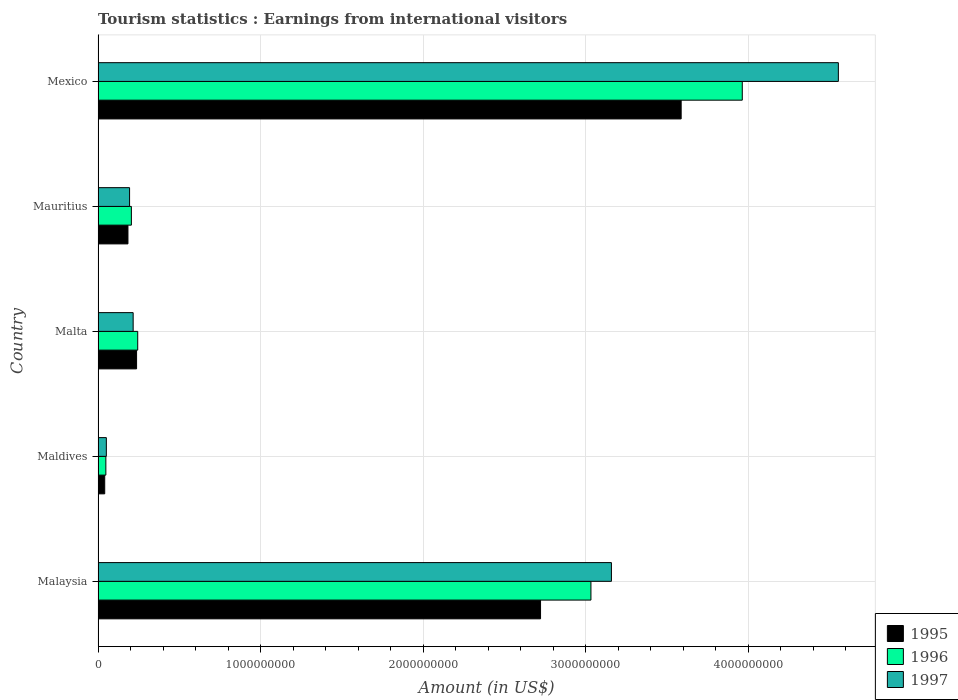How many different coloured bars are there?
Keep it short and to the point. 3. Are the number of bars per tick equal to the number of legend labels?
Your answer should be compact. Yes. Are the number of bars on each tick of the Y-axis equal?
Your answer should be compact. Yes. What is the label of the 1st group of bars from the top?
Keep it short and to the point. Mexico. What is the earnings from international visitors in 1996 in Malta?
Provide a short and direct response. 2.44e+08. Across all countries, what is the maximum earnings from international visitors in 1996?
Your answer should be compact. 3.96e+09. Across all countries, what is the minimum earnings from international visitors in 1997?
Provide a short and direct response. 5.10e+07. In which country was the earnings from international visitors in 1995 maximum?
Provide a succinct answer. Mexico. In which country was the earnings from international visitors in 1996 minimum?
Make the answer very short. Maldives. What is the total earnings from international visitors in 1996 in the graph?
Make the answer very short. 7.49e+09. What is the difference between the earnings from international visitors in 1996 in Malta and that in Mauritius?
Offer a terse response. 3.90e+07. What is the difference between the earnings from international visitors in 1996 in Mauritius and the earnings from international visitors in 1995 in Malta?
Make the answer very short. -3.20e+07. What is the average earnings from international visitors in 1997 per country?
Keep it short and to the point. 1.63e+09. What is the difference between the earnings from international visitors in 1995 and earnings from international visitors in 1996 in Malta?
Your answer should be compact. -7.00e+06. What is the ratio of the earnings from international visitors in 1995 in Malaysia to that in Malta?
Keep it short and to the point. 11.49. Is the earnings from international visitors in 1995 in Maldives less than that in Malta?
Make the answer very short. Yes. What is the difference between the highest and the second highest earnings from international visitors in 1995?
Your answer should be compact. 8.65e+08. What is the difference between the highest and the lowest earnings from international visitors in 1997?
Provide a succinct answer. 4.50e+09. Is the sum of the earnings from international visitors in 1995 in Malta and Mexico greater than the maximum earnings from international visitors in 1996 across all countries?
Your answer should be compact. No. What does the 1st bar from the bottom in Mauritius represents?
Your answer should be compact. 1995. Is it the case that in every country, the sum of the earnings from international visitors in 1995 and earnings from international visitors in 1996 is greater than the earnings from international visitors in 1997?
Offer a terse response. Yes. How many countries are there in the graph?
Provide a succinct answer. 5. Are the values on the major ticks of X-axis written in scientific E-notation?
Your answer should be very brief. No. Does the graph contain grids?
Offer a terse response. Yes. Where does the legend appear in the graph?
Provide a short and direct response. Bottom right. How are the legend labels stacked?
Your answer should be compact. Vertical. What is the title of the graph?
Give a very brief answer. Tourism statistics : Earnings from international visitors. Does "2015" appear as one of the legend labels in the graph?
Your answer should be very brief. No. What is the label or title of the X-axis?
Ensure brevity in your answer.  Amount (in US$). What is the Amount (in US$) of 1995 in Malaysia?
Ensure brevity in your answer.  2.72e+09. What is the Amount (in US$) in 1996 in Malaysia?
Your response must be concise. 3.03e+09. What is the Amount (in US$) in 1997 in Malaysia?
Offer a very short reply. 3.16e+09. What is the Amount (in US$) of 1995 in Maldives?
Your answer should be very brief. 4.10e+07. What is the Amount (in US$) of 1996 in Maldives?
Give a very brief answer. 4.80e+07. What is the Amount (in US$) of 1997 in Maldives?
Your response must be concise. 5.10e+07. What is the Amount (in US$) in 1995 in Malta?
Give a very brief answer. 2.37e+08. What is the Amount (in US$) of 1996 in Malta?
Keep it short and to the point. 2.44e+08. What is the Amount (in US$) in 1997 in Malta?
Your answer should be compact. 2.16e+08. What is the Amount (in US$) of 1995 in Mauritius?
Provide a succinct answer. 1.84e+08. What is the Amount (in US$) in 1996 in Mauritius?
Make the answer very short. 2.05e+08. What is the Amount (in US$) in 1997 in Mauritius?
Your answer should be very brief. 1.94e+08. What is the Amount (in US$) of 1995 in Mexico?
Make the answer very short. 3.59e+09. What is the Amount (in US$) of 1996 in Mexico?
Keep it short and to the point. 3.96e+09. What is the Amount (in US$) in 1997 in Mexico?
Keep it short and to the point. 4.55e+09. Across all countries, what is the maximum Amount (in US$) of 1995?
Ensure brevity in your answer.  3.59e+09. Across all countries, what is the maximum Amount (in US$) in 1996?
Keep it short and to the point. 3.96e+09. Across all countries, what is the maximum Amount (in US$) of 1997?
Provide a succinct answer. 4.55e+09. Across all countries, what is the minimum Amount (in US$) of 1995?
Provide a short and direct response. 4.10e+07. Across all countries, what is the minimum Amount (in US$) of 1996?
Your answer should be very brief. 4.80e+07. Across all countries, what is the minimum Amount (in US$) in 1997?
Ensure brevity in your answer.  5.10e+07. What is the total Amount (in US$) of 1995 in the graph?
Give a very brief answer. 6.77e+09. What is the total Amount (in US$) of 1996 in the graph?
Keep it short and to the point. 7.49e+09. What is the total Amount (in US$) in 1997 in the graph?
Ensure brevity in your answer.  8.17e+09. What is the difference between the Amount (in US$) of 1995 in Malaysia and that in Maldives?
Give a very brief answer. 2.68e+09. What is the difference between the Amount (in US$) of 1996 in Malaysia and that in Maldives?
Your response must be concise. 2.98e+09. What is the difference between the Amount (in US$) of 1997 in Malaysia and that in Maldives?
Offer a terse response. 3.11e+09. What is the difference between the Amount (in US$) of 1995 in Malaysia and that in Malta?
Make the answer very short. 2.48e+09. What is the difference between the Amount (in US$) of 1996 in Malaysia and that in Malta?
Your answer should be compact. 2.79e+09. What is the difference between the Amount (in US$) of 1997 in Malaysia and that in Malta?
Your answer should be compact. 2.94e+09. What is the difference between the Amount (in US$) of 1995 in Malaysia and that in Mauritius?
Your answer should be very brief. 2.54e+09. What is the difference between the Amount (in US$) of 1996 in Malaysia and that in Mauritius?
Offer a very short reply. 2.83e+09. What is the difference between the Amount (in US$) in 1997 in Malaysia and that in Mauritius?
Ensure brevity in your answer.  2.96e+09. What is the difference between the Amount (in US$) in 1995 in Malaysia and that in Mexico?
Offer a terse response. -8.65e+08. What is the difference between the Amount (in US$) in 1996 in Malaysia and that in Mexico?
Provide a short and direct response. -9.31e+08. What is the difference between the Amount (in US$) in 1997 in Malaysia and that in Mexico?
Your answer should be very brief. -1.40e+09. What is the difference between the Amount (in US$) in 1995 in Maldives and that in Malta?
Provide a short and direct response. -1.96e+08. What is the difference between the Amount (in US$) of 1996 in Maldives and that in Malta?
Your answer should be compact. -1.96e+08. What is the difference between the Amount (in US$) in 1997 in Maldives and that in Malta?
Make the answer very short. -1.65e+08. What is the difference between the Amount (in US$) in 1995 in Maldives and that in Mauritius?
Keep it short and to the point. -1.43e+08. What is the difference between the Amount (in US$) of 1996 in Maldives and that in Mauritius?
Your answer should be very brief. -1.57e+08. What is the difference between the Amount (in US$) in 1997 in Maldives and that in Mauritius?
Ensure brevity in your answer.  -1.43e+08. What is the difference between the Amount (in US$) of 1995 in Maldives and that in Mexico?
Provide a short and direct response. -3.55e+09. What is the difference between the Amount (in US$) in 1996 in Maldives and that in Mexico?
Offer a terse response. -3.92e+09. What is the difference between the Amount (in US$) in 1997 in Maldives and that in Mexico?
Offer a terse response. -4.50e+09. What is the difference between the Amount (in US$) in 1995 in Malta and that in Mauritius?
Your answer should be very brief. 5.30e+07. What is the difference between the Amount (in US$) in 1996 in Malta and that in Mauritius?
Provide a succinct answer. 3.90e+07. What is the difference between the Amount (in US$) in 1997 in Malta and that in Mauritius?
Offer a very short reply. 2.20e+07. What is the difference between the Amount (in US$) of 1995 in Malta and that in Mexico?
Provide a succinct answer. -3.35e+09. What is the difference between the Amount (in US$) of 1996 in Malta and that in Mexico?
Provide a short and direct response. -3.72e+09. What is the difference between the Amount (in US$) of 1997 in Malta and that in Mexico?
Ensure brevity in your answer.  -4.34e+09. What is the difference between the Amount (in US$) of 1995 in Mauritius and that in Mexico?
Your response must be concise. -3.40e+09. What is the difference between the Amount (in US$) in 1996 in Mauritius and that in Mexico?
Ensure brevity in your answer.  -3.76e+09. What is the difference between the Amount (in US$) of 1997 in Mauritius and that in Mexico?
Make the answer very short. -4.36e+09. What is the difference between the Amount (in US$) of 1995 in Malaysia and the Amount (in US$) of 1996 in Maldives?
Provide a short and direct response. 2.67e+09. What is the difference between the Amount (in US$) in 1995 in Malaysia and the Amount (in US$) in 1997 in Maldives?
Offer a terse response. 2.67e+09. What is the difference between the Amount (in US$) of 1996 in Malaysia and the Amount (in US$) of 1997 in Maldives?
Provide a short and direct response. 2.98e+09. What is the difference between the Amount (in US$) of 1995 in Malaysia and the Amount (in US$) of 1996 in Malta?
Make the answer very short. 2.48e+09. What is the difference between the Amount (in US$) in 1995 in Malaysia and the Amount (in US$) in 1997 in Malta?
Your answer should be compact. 2.51e+09. What is the difference between the Amount (in US$) in 1996 in Malaysia and the Amount (in US$) in 1997 in Malta?
Provide a succinct answer. 2.82e+09. What is the difference between the Amount (in US$) in 1995 in Malaysia and the Amount (in US$) in 1996 in Mauritius?
Offer a very short reply. 2.52e+09. What is the difference between the Amount (in US$) of 1995 in Malaysia and the Amount (in US$) of 1997 in Mauritius?
Your answer should be compact. 2.53e+09. What is the difference between the Amount (in US$) in 1996 in Malaysia and the Amount (in US$) in 1997 in Mauritius?
Offer a terse response. 2.84e+09. What is the difference between the Amount (in US$) in 1995 in Malaysia and the Amount (in US$) in 1996 in Mexico?
Offer a very short reply. -1.24e+09. What is the difference between the Amount (in US$) in 1995 in Malaysia and the Amount (in US$) in 1997 in Mexico?
Ensure brevity in your answer.  -1.83e+09. What is the difference between the Amount (in US$) in 1996 in Malaysia and the Amount (in US$) in 1997 in Mexico?
Offer a very short reply. -1.52e+09. What is the difference between the Amount (in US$) of 1995 in Maldives and the Amount (in US$) of 1996 in Malta?
Make the answer very short. -2.03e+08. What is the difference between the Amount (in US$) of 1995 in Maldives and the Amount (in US$) of 1997 in Malta?
Your response must be concise. -1.75e+08. What is the difference between the Amount (in US$) in 1996 in Maldives and the Amount (in US$) in 1997 in Malta?
Make the answer very short. -1.68e+08. What is the difference between the Amount (in US$) in 1995 in Maldives and the Amount (in US$) in 1996 in Mauritius?
Provide a short and direct response. -1.64e+08. What is the difference between the Amount (in US$) in 1995 in Maldives and the Amount (in US$) in 1997 in Mauritius?
Ensure brevity in your answer.  -1.53e+08. What is the difference between the Amount (in US$) of 1996 in Maldives and the Amount (in US$) of 1997 in Mauritius?
Your response must be concise. -1.46e+08. What is the difference between the Amount (in US$) in 1995 in Maldives and the Amount (in US$) in 1996 in Mexico?
Provide a short and direct response. -3.92e+09. What is the difference between the Amount (in US$) of 1995 in Maldives and the Amount (in US$) of 1997 in Mexico?
Your answer should be very brief. -4.51e+09. What is the difference between the Amount (in US$) in 1996 in Maldives and the Amount (in US$) in 1997 in Mexico?
Give a very brief answer. -4.51e+09. What is the difference between the Amount (in US$) in 1995 in Malta and the Amount (in US$) in 1996 in Mauritius?
Provide a short and direct response. 3.20e+07. What is the difference between the Amount (in US$) of 1995 in Malta and the Amount (in US$) of 1997 in Mauritius?
Your answer should be very brief. 4.30e+07. What is the difference between the Amount (in US$) in 1995 in Malta and the Amount (in US$) in 1996 in Mexico?
Offer a very short reply. -3.73e+09. What is the difference between the Amount (in US$) in 1995 in Malta and the Amount (in US$) in 1997 in Mexico?
Give a very brief answer. -4.32e+09. What is the difference between the Amount (in US$) in 1996 in Malta and the Amount (in US$) in 1997 in Mexico?
Your answer should be compact. -4.31e+09. What is the difference between the Amount (in US$) of 1995 in Mauritius and the Amount (in US$) of 1996 in Mexico?
Ensure brevity in your answer.  -3.78e+09. What is the difference between the Amount (in US$) of 1995 in Mauritius and the Amount (in US$) of 1997 in Mexico?
Keep it short and to the point. -4.37e+09. What is the difference between the Amount (in US$) of 1996 in Mauritius and the Amount (in US$) of 1997 in Mexico?
Your response must be concise. -4.35e+09. What is the average Amount (in US$) of 1995 per country?
Keep it short and to the point. 1.35e+09. What is the average Amount (in US$) in 1996 per country?
Keep it short and to the point. 1.50e+09. What is the average Amount (in US$) in 1997 per country?
Your answer should be compact. 1.63e+09. What is the difference between the Amount (in US$) in 1995 and Amount (in US$) in 1996 in Malaysia?
Your response must be concise. -3.10e+08. What is the difference between the Amount (in US$) in 1995 and Amount (in US$) in 1997 in Malaysia?
Offer a very short reply. -4.36e+08. What is the difference between the Amount (in US$) of 1996 and Amount (in US$) of 1997 in Malaysia?
Give a very brief answer. -1.26e+08. What is the difference between the Amount (in US$) in 1995 and Amount (in US$) in 1996 in Maldives?
Make the answer very short. -7.00e+06. What is the difference between the Amount (in US$) in 1995 and Amount (in US$) in 1997 in Maldives?
Offer a terse response. -1.00e+07. What is the difference between the Amount (in US$) of 1995 and Amount (in US$) of 1996 in Malta?
Keep it short and to the point. -7.00e+06. What is the difference between the Amount (in US$) in 1995 and Amount (in US$) in 1997 in Malta?
Your response must be concise. 2.10e+07. What is the difference between the Amount (in US$) of 1996 and Amount (in US$) of 1997 in Malta?
Your answer should be compact. 2.80e+07. What is the difference between the Amount (in US$) in 1995 and Amount (in US$) in 1996 in Mauritius?
Your answer should be compact. -2.10e+07. What is the difference between the Amount (in US$) of 1995 and Amount (in US$) of 1997 in Mauritius?
Keep it short and to the point. -1.00e+07. What is the difference between the Amount (in US$) in 1996 and Amount (in US$) in 1997 in Mauritius?
Your answer should be compact. 1.10e+07. What is the difference between the Amount (in US$) of 1995 and Amount (in US$) of 1996 in Mexico?
Make the answer very short. -3.76e+08. What is the difference between the Amount (in US$) in 1995 and Amount (in US$) in 1997 in Mexico?
Provide a succinct answer. -9.67e+08. What is the difference between the Amount (in US$) of 1996 and Amount (in US$) of 1997 in Mexico?
Your answer should be very brief. -5.91e+08. What is the ratio of the Amount (in US$) in 1995 in Malaysia to that in Maldives?
Keep it short and to the point. 66.39. What is the ratio of the Amount (in US$) of 1996 in Malaysia to that in Maldives?
Make the answer very short. 63.17. What is the ratio of the Amount (in US$) in 1997 in Malaysia to that in Maldives?
Your response must be concise. 61.92. What is the ratio of the Amount (in US$) of 1995 in Malaysia to that in Malta?
Provide a short and direct response. 11.49. What is the ratio of the Amount (in US$) of 1996 in Malaysia to that in Malta?
Your answer should be very brief. 12.43. What is the ratio of the Amount (in US$) in 1997 in Malaysia to that in Malta?
Offer a terse response. 14.62. What is the ratio of the Amount (in US$) in 1995 in Malaysia to that in Mauritius?
Your answer should be very brief. 14.79. What is the ratio of the Amount (in US$) in 1996 in Malaysia to that in Mauritius?
Your answer should be very brief. 14.79. What is the ratio of the Amount (in US$) of 1997 in Malaysia to that in Mauritius?
Provide a short and direct response. 16.28. What is the ratio of the Amount (in US$) in 1995 in Malaysia to that in Mexico?
Your answer should be very brief. 0.76. What is the ratio of the Amount (in US$) of 1996 in Malaysia to that in Mexico?
Keep it short and to the point. 0.77. What is the ratio of the Amount (in US$) of 1997 in Malaysia to that in Mexico?
Make the answer very short. 0.69. What is the ratio of the Amount (in US$) of 1995 in Maldives to that in Malta?
Your answer should be compact. 0.17. What is the ratio of the Amount (in US$) in 1996 in Maldives to that in Malta?
Offer a very short reply. 0.2. What is the ratio of the Amount (in US$) of 1997 in Maldives to that in Malta?
Make the answer very short. 0.24. What is the ratio of the Amount (in US$) of 1995 in Maldives to that in Mauritius?
Ensure brevity in your answer.  0.22. What is the ratio of the Amount (in US$) in 1996 in Maldives to that in Mauritius?
Your answer should be compact. 0.23. What is the ratio of the Amount (in US$) in 1997 in Maldives to that in Mauritius?
Keep it short and to the point. 0.26. What is the ratio of the Amount (in US$) of 1995 in Maldives to that in Mexico?
Provide a short and direct response. 0.01. What is the ratio of the Amount (in US$) of 1996 in Maldives to that in Mexico?
Provide a succinct answer. 0.01. What is the ratio of the Amount (in US$) in 1997 in Maldives to that in Mexico?
Keep it short and to the point. 0.01. What is the ratio of the Amount (in US$) in 1995 in Malta to that in Mauritius?
Your answer should be very brief. 1.29. What is the ratio of the Amount (in US$) in 1996 in Malta to that in Mauritius?
Give a very brief answer. 1.19. What is the ratio of the Amount (in US$) of 1997 in Malta to that in Mauritius?
Your answer should be very brief. 1.11. What is the ratio of the Amount (in US$) of 1995 in Malta to that in Mexico?
Provide a succinct answer. 0.07. What is the ratio of the Amount (in US$) in 1996 in Malta to that in Mexico?
Offer a very short reply. 0.06. What is the ratio of the Amount (in US$) in 1997 in Malta to that in Mexico?
Keep it short and to the point. 0.05. What is the ratio of the Amount (in US$) of 1995 in Mauritius to that in Mexico?
Ensure brevity in your answer.  0.05. What is the ratio of the Amount (in US$) in 1996 in Mauritius to that in Mexico?
Provide a short and direct response. 0.05. What is the ratio of the Amount (in US$) of 1997 in Mauritius to that in Mexico?
Your response must be concise. 0.04. What is the difference between the highest and the second highest Amount (in US$) in 1995?
Your answer should be compact. 8.65e+08. What is the difference between the highest and the second highest Amount (in US$) in 1996?
Provide a succinct answer. 9.31e+08. What is the difference between the highest and the second highest Amount (in US$) of 1997?
Your answer should be compact. 1.40e+09. What is the difference between the highest and the lowest Amount (in US$) in 1995?
Your answer should be compact. 3.55e+09. What is the difference between the highest and the lowest Amount (in US$) of 1996?
Give a very brief answer. 3.92e+09. What is the difference between the highest and the lowest Amount (in US$) of 1997?
Make the answer very short. 4.50e+09. 